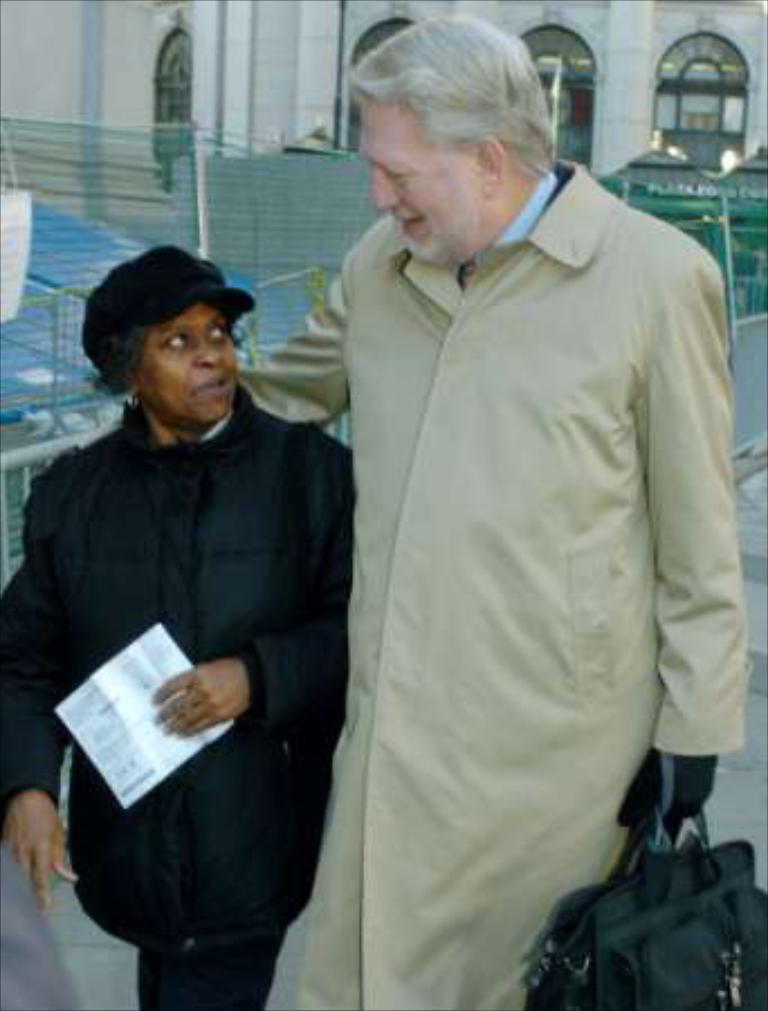Can you describe this image briefly? In this picture we can see two people holding a paper and a bag with their hands. In the background we can see fences, some objects and a building with windows. 